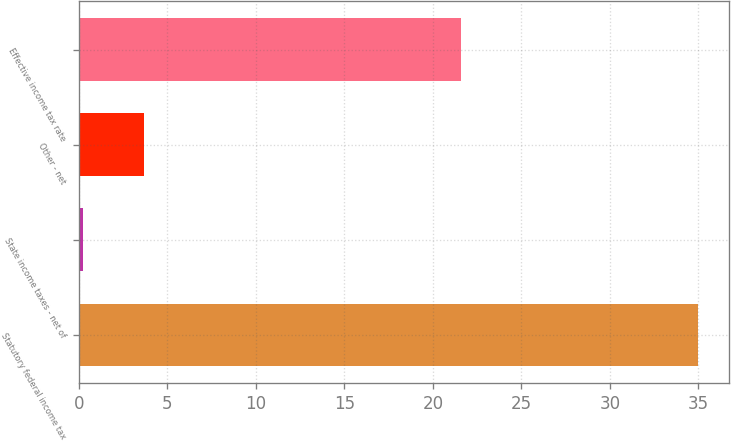Convert chart. <chart><loc_0><loc_0><loc_500><loc_500><bar_chart><fcel>Statutory federal income tax<fcel>State income taxes - net of<fcel>Other - net<fcel>Effective income tax rate<nl><fcel>35<fcel>0.2<fcel>3.68<fcel>21.6<nl></chart> 